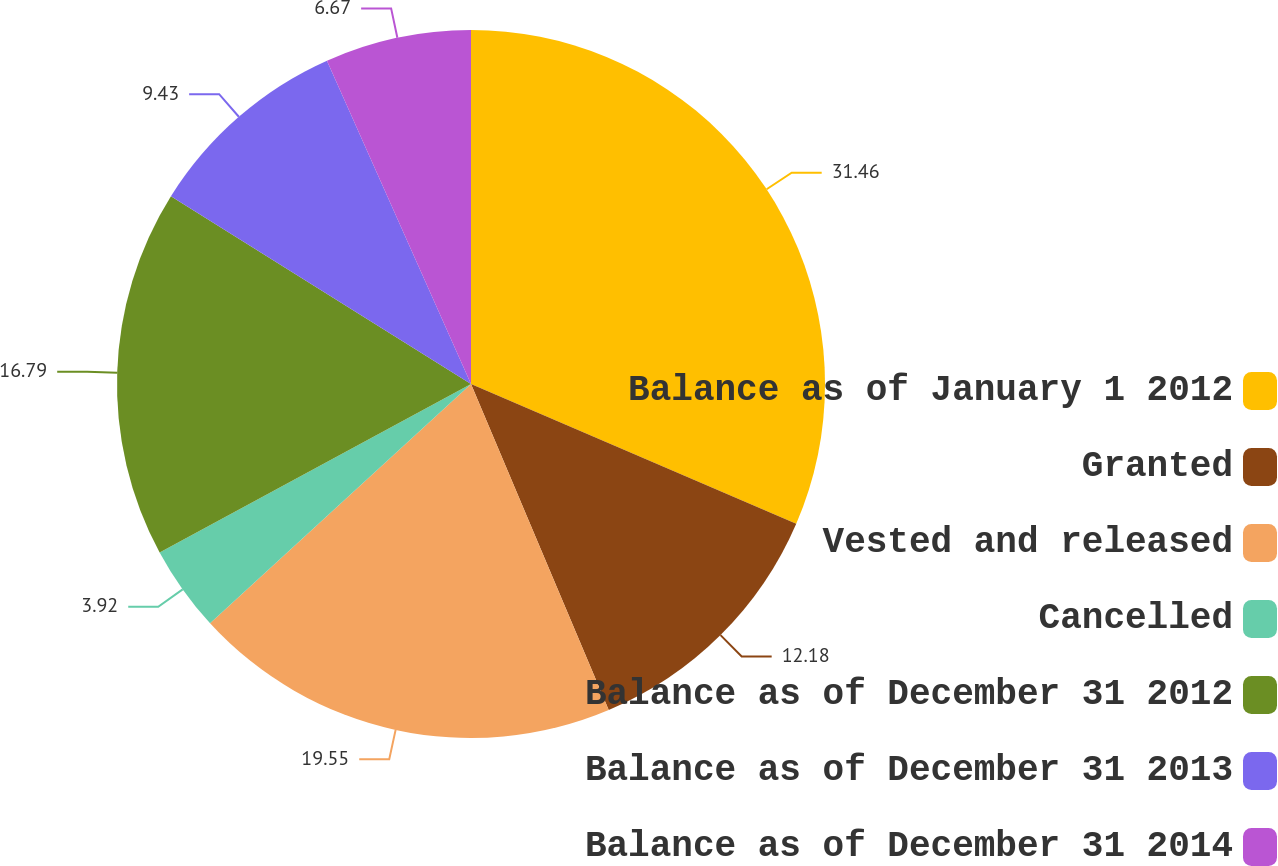Convert chart. <chart><loc_0><loc_0><loc_500><loc_500><pie_chart><fcel>Balance as of January 1 2012<fcel>Granted<fcel>Vested and released<fcel>Cancelled<fcel>Balance as of December 31 2012<fcel>Balance as of December 31 2013<fcel>Balance as of December 31 2014<nl><fcel>31.46%<fcel>12.18%<fcel>19.55%<fcel>3.92%<fcel>16.79%<fcel>9.43%<fcel>6.67%<nl></chart> 